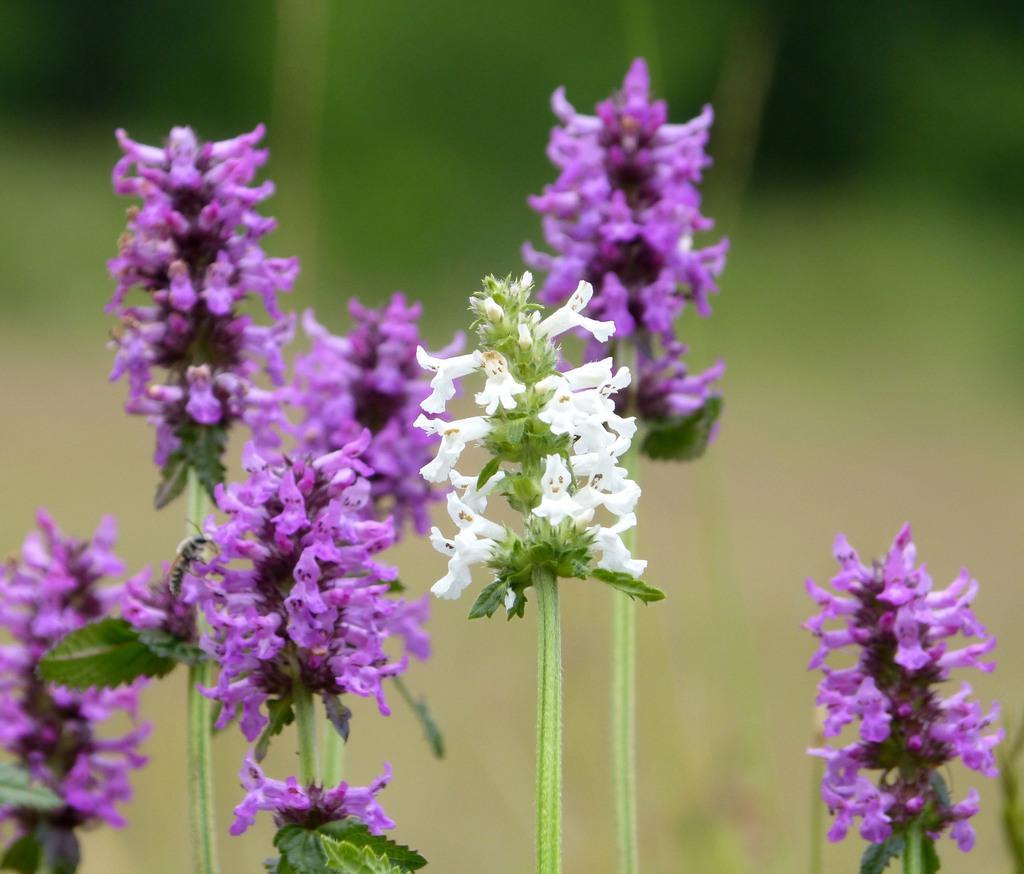Can you describe this image briefly? In this picture I can see few flowers and I can see blurry background. 